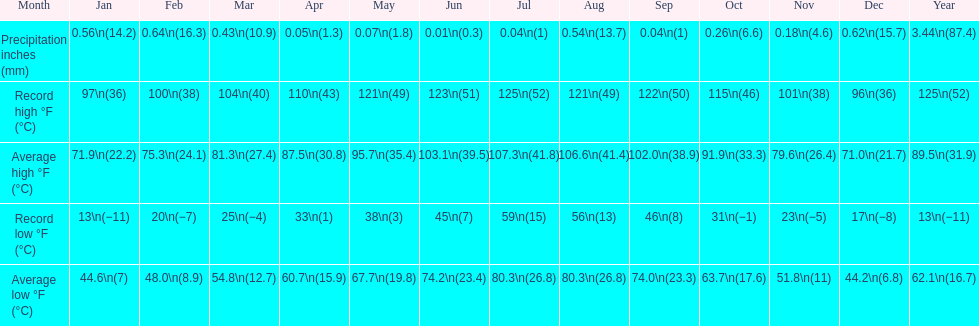How long was the monthly average temperature 100 degrees or more? 4 months. 